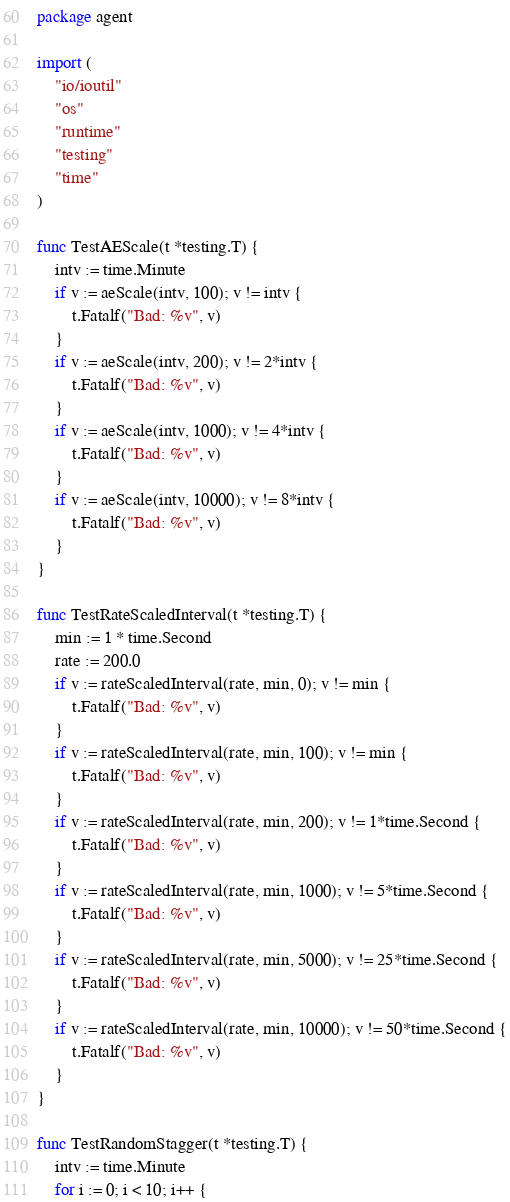<code> <loc_0><loc_0><loc_500><loc_500><_Go_>package agent

import (
	"io/ioutil"
	"os"
	"runtime"
	"testing"
	"time"
)

func TestAEScale(t *testing.T) {
	intv := time.Minute
	if v := aeScale(intv, 100); v != intv {
		t.Fatalf("Bad: %v", v)
	}
	if v := aeScale(intv, 200); v != 2*intv {
		t.Fatalf("Bad: %v", v)
	}
	if v := aeScale(intv, 1000); v != 4*intv {
		t.Fatalf("Bad: %v", v)
	}
	if v := aeScale(intv, 10000); v != 8*intv {
		t.Fatalf("Bad: %v", v)
	}
}

func TestRateScaledInterval(t *testing.T) {
	min := 1 * time.Second
	rate := 200.0
	if v := rateScaledInterval(rate, min, 0); v != min {
		t.Fatalf("Bad: %v", v)
	}
	if v := rateScaledInterval(rate, min, 100); v != min {
		t.Fatalf("Bad: %v", v)
	}
	if v := rateScaledInterval(rate, min, 200); v != 1*time.Second {
		t.Fatalf("Bad: %v", v)
	}
	if v := rateScaledInterval(rate, min, 1000); v != 5*time.Second {
		t.Fatalf("Bad: %v", v)
	}
	if v := rateScaledInterval(rate, min, 5000); v != 25*time.Second {
		t.Fatalf("Bad: %v", v)
	}
	if v := rateScaledInterval(rate, min, 10000); v != 50*time.Second {
		t.Fatalf("Bad: %v", v)
	}
}

func TestRandomStagger(t *testing.T) {
	intv := time.Minute
	for i := 0; i < 10; i++ {</code> 